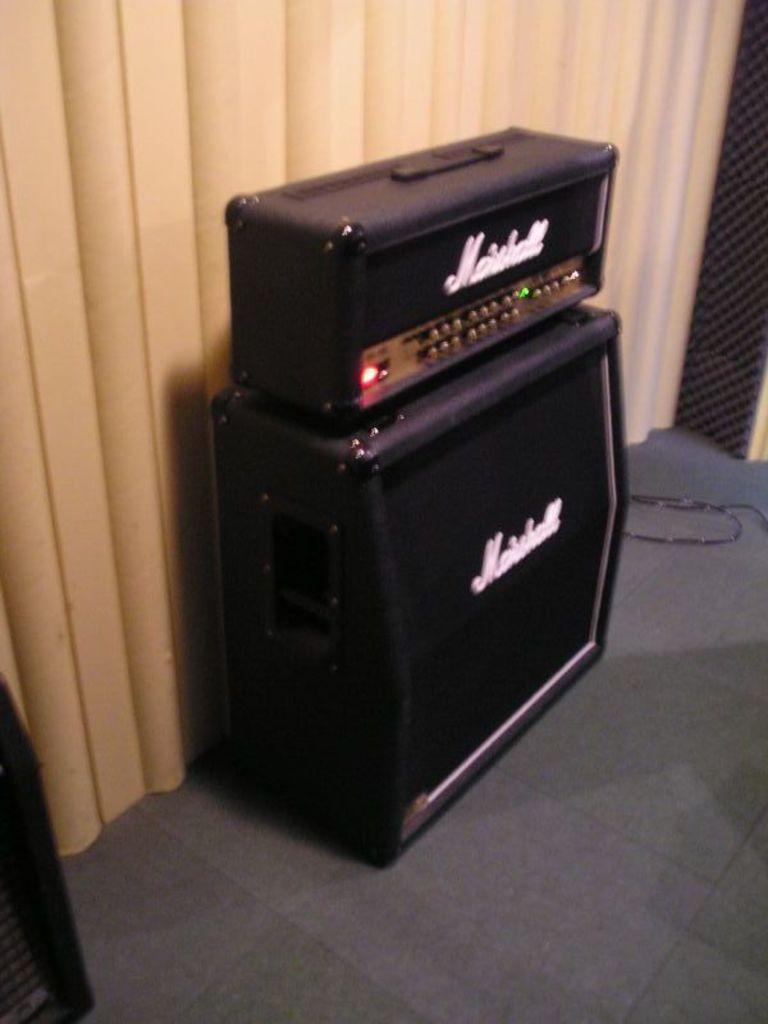In one or two sentences, can you explain what this image depicts? In this image, this looks like a speaker, which is placed on the floor. I think this is an electronic device, which is kept on the speaker. These are the curtains hanging. At the bottom left corner of the image, I can see another object. 